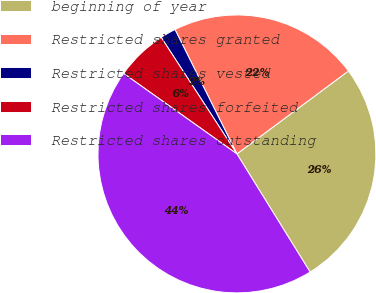Convert chart. <chart><loc_0><loc_0><loc_500><loc_500><pie_chart><fcel>beginning of year<fcel>Restricted shares granted<fcel>Restricted shares vested<fcel>Restricted shares forfeited<fcel>Restricted shares outstanding<nl><fcel>26.35%<fcel>22.17%<fcel>1.82%<fcel>6.0%<fcel>43.65%<nl></chart> 